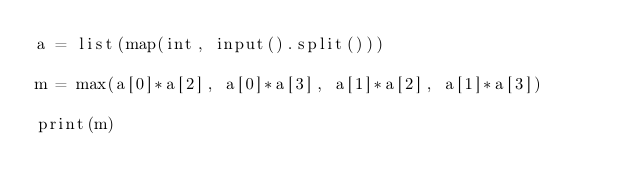<code> <loc_0><loc_0><loc_500><loc_500><_Python_>a = list(map(int, input().split()))

m = max(a[0]*a[2], a[0]*a[3], a[1]*a[2], a[1]*a[3])

print(m)</code> 